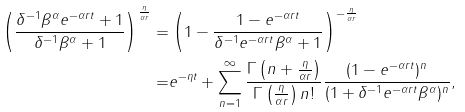Convert formula to latex. <formula><loc_0><loc_0><loc_500><loc_500>\left ( \frac { \delta ^ { - 1 } \beta ^ { \alpha } e ^ { - \alpha r t } + 1 } { \delta ^ { - 1 } \beta ^ { \alpha } + 1 } \right ) ^ { \frac { \eta } { \alpha r } } = & \left ( 1 - \frac { 1 - e ^ { - \alpha r t } } { \delta ^ { - 1 } e ^ { - \alpha r t } \beta ^ { \alpha } + 1 } \right ) ^ { - \frac { \eta } { \alpha r } } \\ = & e ^ { - \eta t } + \sum _ { n = 1 } ^ { \infty } \frac { \Gamma \left ( n + \frac { \eta } { \alpha r } \right ) } { \Gamma \left ( \frac { \eta } { \alpha r } \right ) n ! } \frac { ( 1 - e ^ { - \alpha r t } ) ^ { n } } { ( 1 + \delta ^ { - 1 } e ^ { - \alpha r t } \beta ^ { \alpha } ) ^ { n } } ,</formula> 